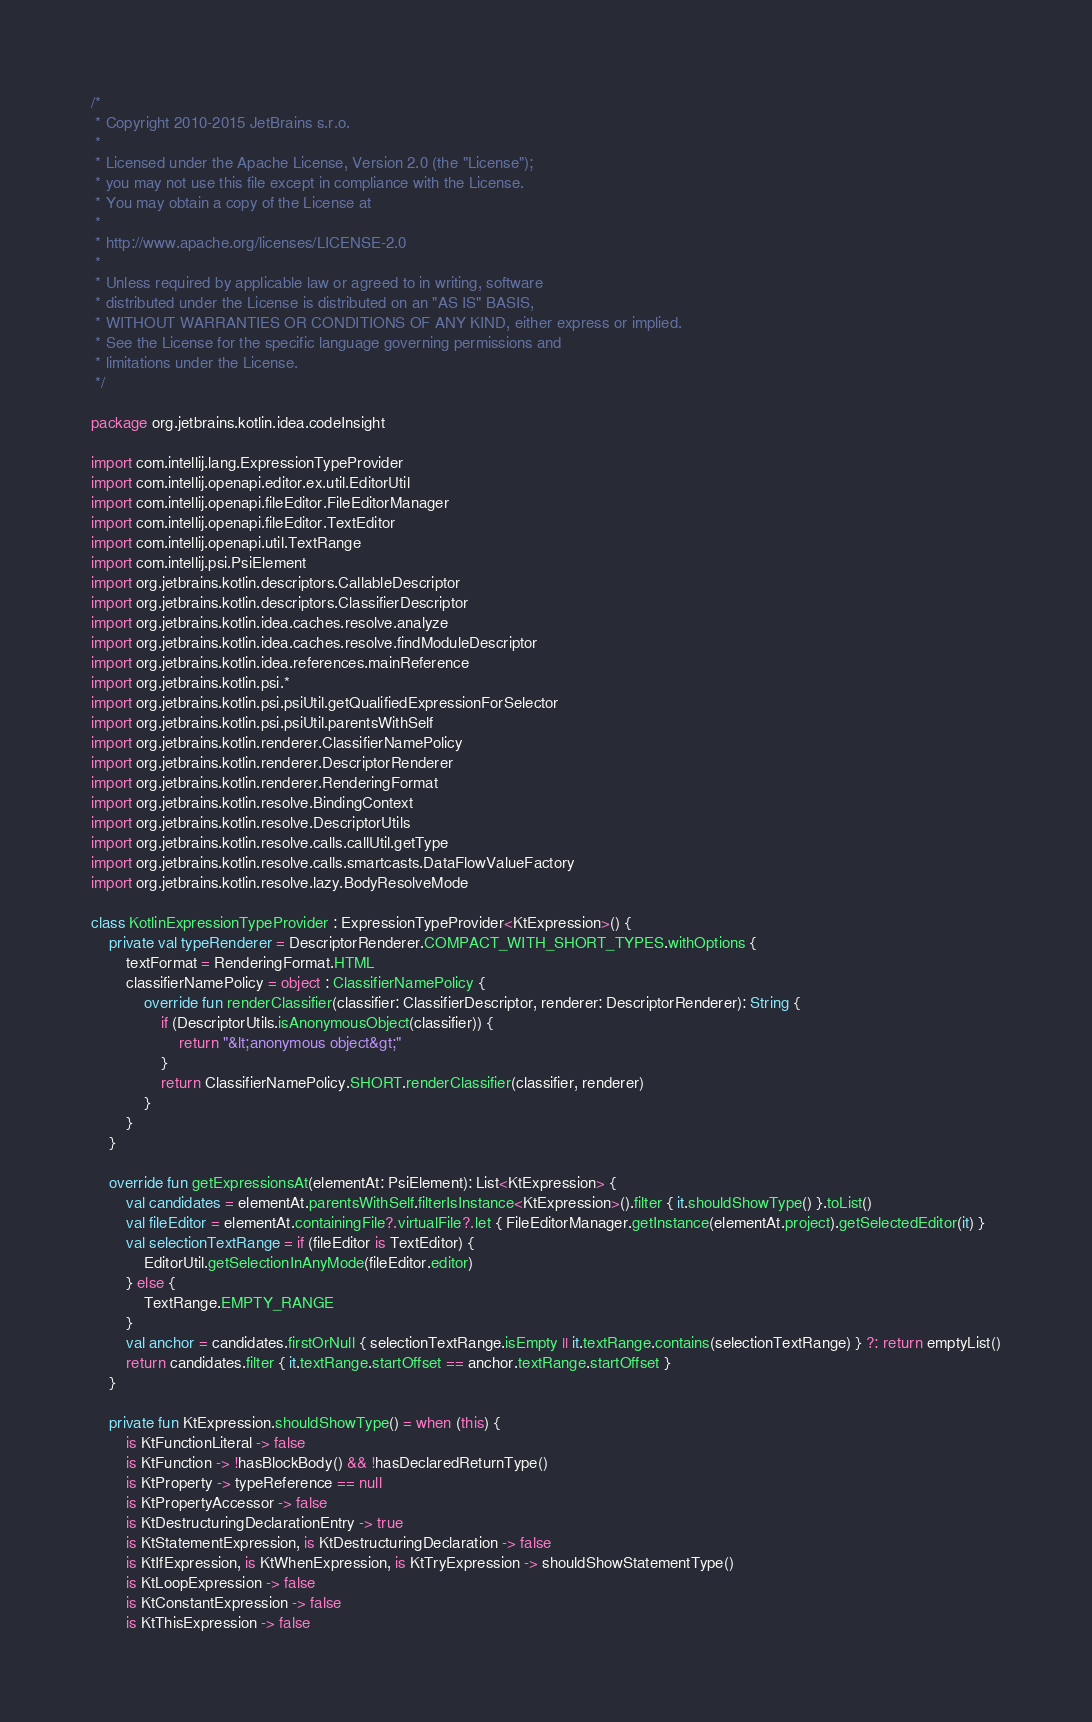Convert code to text. <code><loc_0><loc_0><loc_500><loc_500><_Kotlin_>/*
 * Copyright 2010-2015 JetBrains s.r.o.
 *
 * Licensed under the Apache License, Version 2.0 (the "License");
 * you may not use this file except in compliance with the License.
 * You may obtain a copy of the License at
 *
 * http://www.apache.org/licenses/LICENSE-2.0
 *
 * Unless required by applicable law or agreed to in writing, software
 * distributed under the License is distributed on an "AS IS" BASIS,
 * WITHOUT WARRANTIES OR CONDITIONS OF ANY KIND, either express or implied.
 * See the License for the specific language governing permissions and
 * limitations under the License.
 */

package org.jetbrains.kotlin.idea.codeInsight

import com.intellij.lang.ExpressionTypeProvider
import com.intellij.openapi.editor.ex.util.EditorUtil
import com.intellij.openapi.fileEditor.FileEditorManager
import com.intellij.openapi.fileEditor.TextEditor
import com.intellij.openapi.util.TextRange
import com.intellij.psi.PsiElement
import org.jetbrains.kotlin.descriptors.CallableDescriptor
import org.jetbrains.kotlin.descriptors.ClassifierDescriptor
import org.jetbrains.kotlin.idea.caches.resolve.analyze
import org.jetbrains.kotlin.idea.caches.resolve.findModuleDescriptor
import org.jetbrains.kotlin.idea.references.mainReference
import org.jetbrains.kotlin.psi.*
import org.jetbrains.kotlin.psi.psiUtil.getQualifiedExpressionForSelector
import org.jetbrains.kotlin.psi.psiUtil.parentsWithSelf
import org.jetbrains.kotlin.renderer.ClassifierNamePolicy
import org.jetbrains.kotlin.renderer.DescriptorRenderer
import org.jetbrains.kotlin.renderer.RenderingFormat
import org.jetbrains.kotlin.resolve.BindingContext
import org.jetbrains.kotlin.resolve.DescriptorUtils
import org.jetbrains.kotlin.resolve.calls.callUtil.getType
import org.jetbrains.kotlin.resolve.calls.smartcasts.DataFlowValueFactory
import org.jetbrains.kotlin.resolve.lazy.BodyResolveMode

class KotlinExpressionTypeProvider : ExpressionTypeProvider<KtExpression>() {
    private val typeRenderer = DescriptorRenderer.COMPACT_WITH_SHORT_TYPES.withOptions {
        textFormat = RenderingFormat.HTML
        classifierNamePolicy = object : ClassifierNamePolicy {
            override fun renderClassifier(classifier: ClassifierDescriptor, renderer: DescriptorRenderer): String {
                if (DescriptorUtils.isAnonymousObject(classifier)) {
                    return "&lt;anonymous object&gt;"
                }
                return ClassifierNamePolicy.SHORT.renderClassifier(classifier, renderer)
            }
        }
    }

    override fun getExpressionsAt(elementAt: PsiElement): List<KtExpression> {
        val candidates = elementAt.parentsWithSelf.filterIsInstance<KtExpression>().filter { it.shouldShowType() }.toList()
        val fileEditor = elementAt.containingFile?.virtualFile?.let { FileEditorManager.getInstance(elementAt.project).getSelectedEditor(it) }
        val selectionTextRange = if (fileEditor is TextEditor) {
            EditorUtil.getSelectionInAnyMode(fileEditor.editor)
        } else {
            TextRange.EMPTY_RANGE
        }
        val anchor = candidates.firstOrNull { selectionTextRange.isEmpty || it.textRange.contains(selectionTextRange) } ?: return emptyList()
        return candidates.filter { it.textRange.startOffset == anchor.textRange.startOffset }
    }

    private fun KtExpression.shouldShowType() = when (this) {
        is KtFunctionLiteral -> false
        is KtFunction -> !hasBlockBody() && !hasDeclaredReturnType()
        is KtProperty -> typeReference == null
        is KtPropertyAccessor -> false
        is KtDestructuringDeclarationEntry -> true
        is KtStatementExpression, is KtDestructuringDeclaration -> false
        is KtIfExpression, is KtWhenExpression, is KtTryExpression -> shouldShowStatementType()
        is KtLoopExpression -> false
        is KtConstantExpression -> false
        is KtThisExpression -> false</code> 